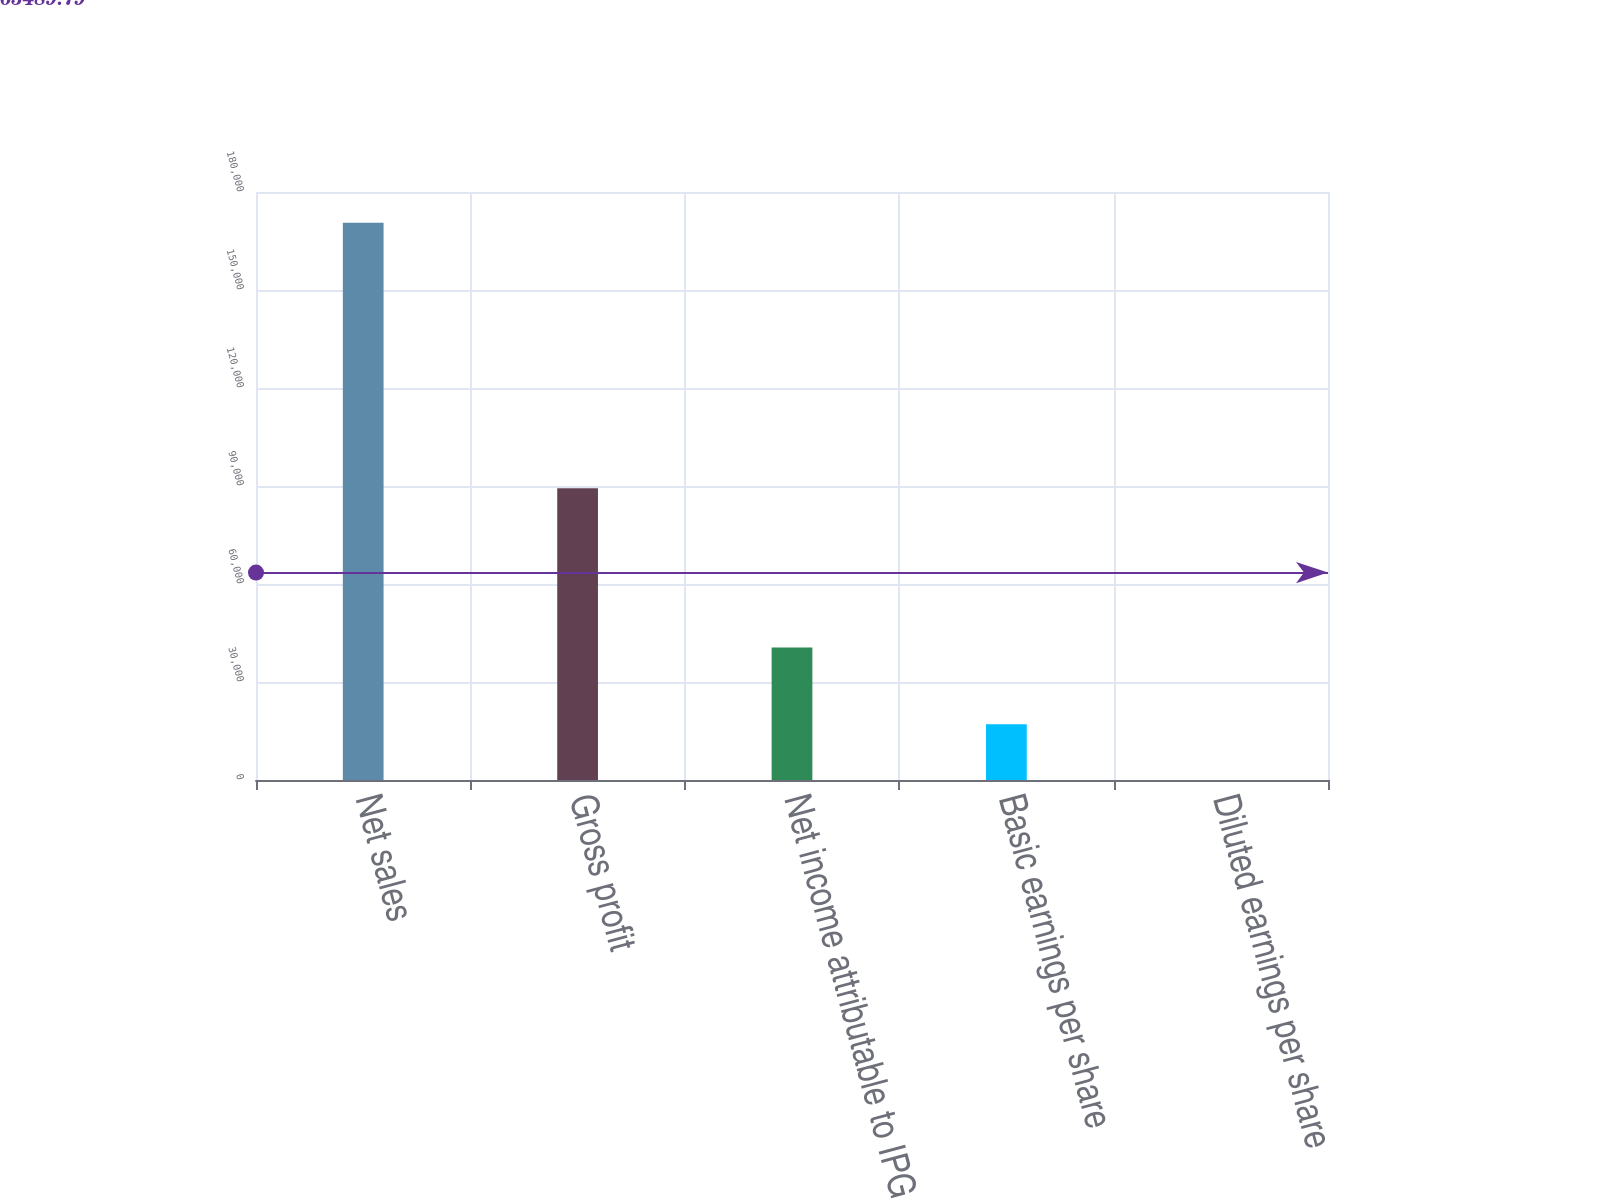Convert chart. <chart><loc_0><loc_0><loc_500><loc_500><bar_chart><fcel>Net sales<fcel>Gross profit<fcel>Net income attributable to IPG<fcel>Basic earnings per share<fcel>Diluted earnings per share<nl><fcel>170575<fcel>89284<fcel>40531<fcel>17058.2<fcel>0.77<nl></chart> 